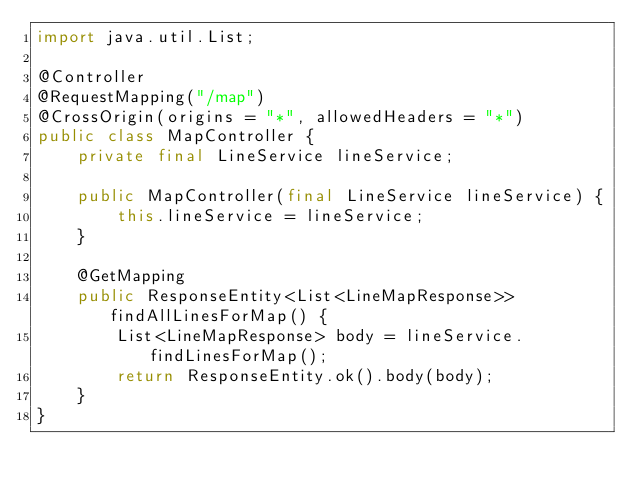<code> <loc_0><loc_0><loc_500><loc_500><_Java_>import java.util.List;

@Controller
@RequestMapping("/map")
@CrossOrigin(origins = "*", allowedHeaders = "*")
public class MapController {
    private final LineService lineService;

    public MapController(final LineService lineService) {
        this.lineService = lineService;
    }

    @GetMapping
    public ResponseEntity<List<LineMapResponse>> findAllLinesForMap() {
        List<LineMapResponse> body = lineService.findLinesForMap();
        return ResponseEntity.ok().body(body);
    }
}
</code> 